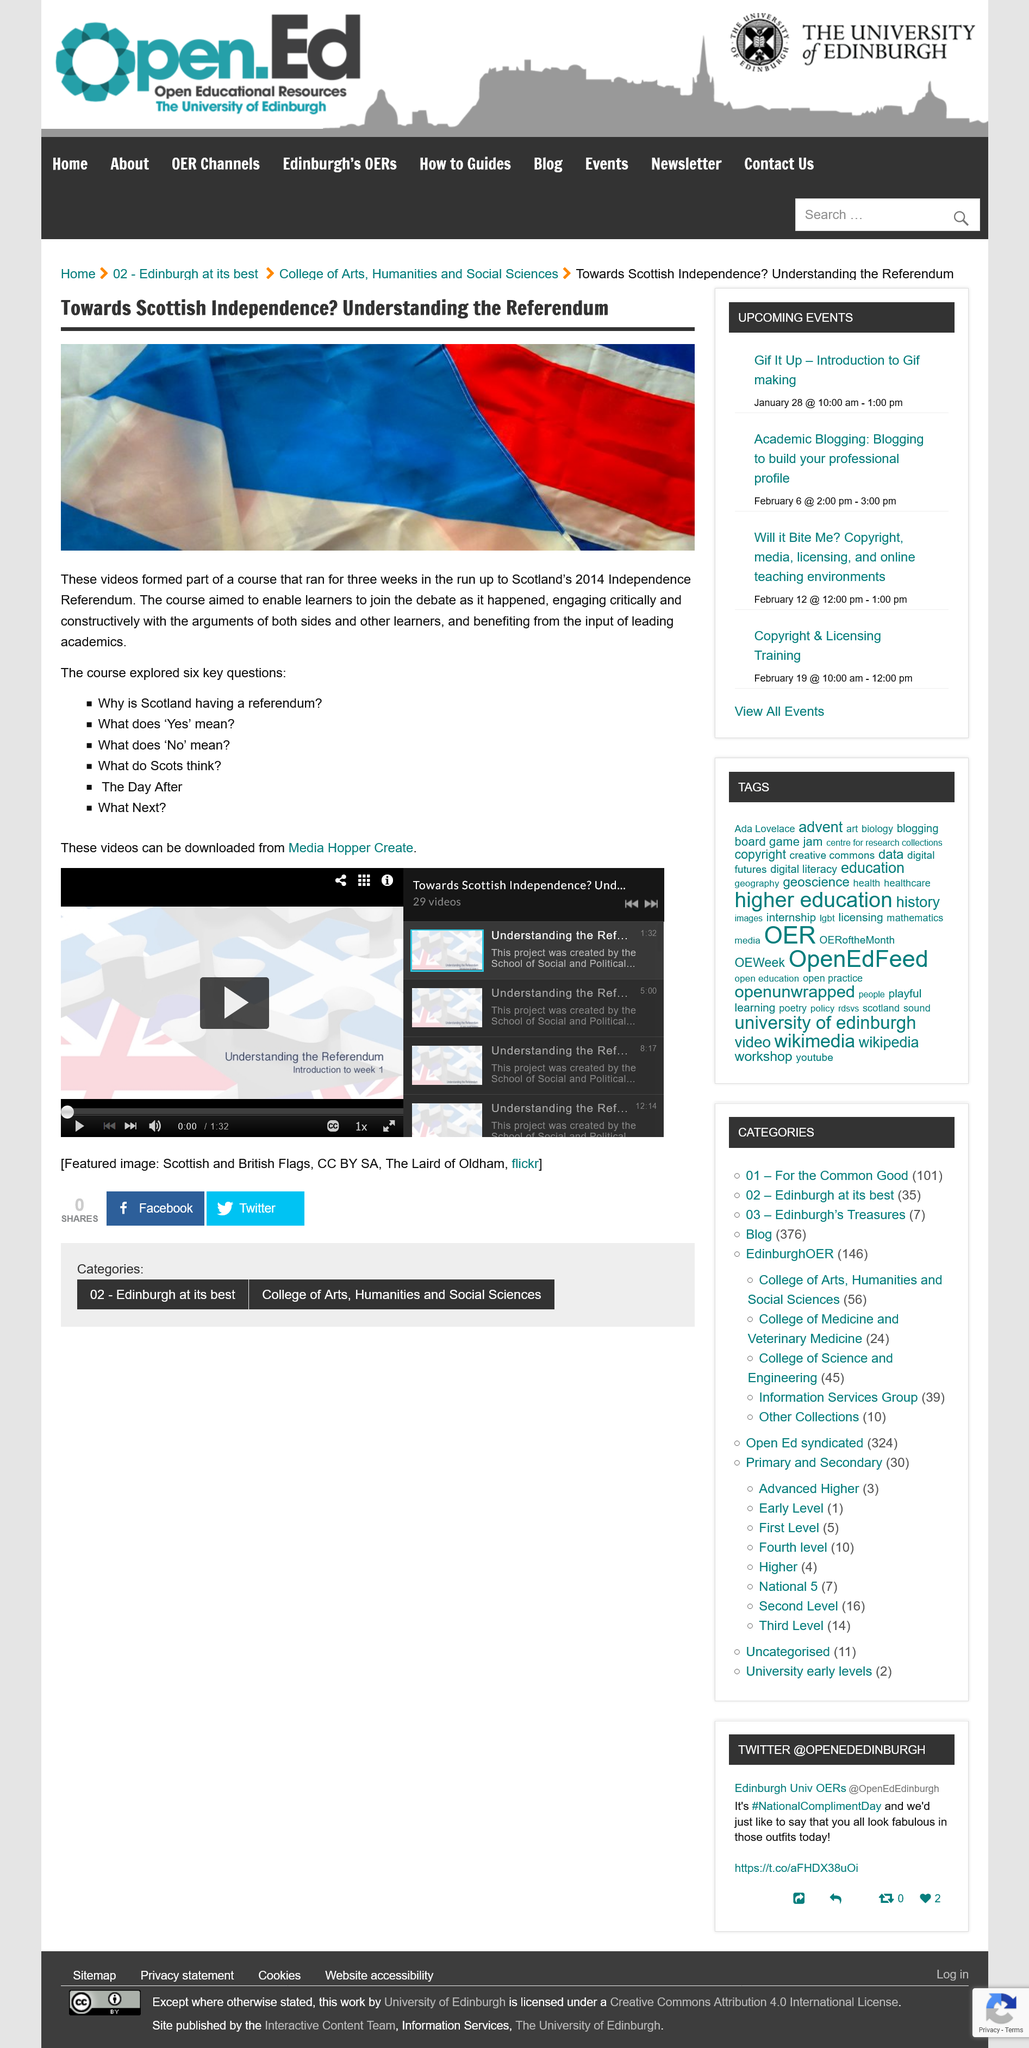Mention a couple of crucial points in this snapshot. Scotland's Independence Referendum is scheduled to take place in 2014. Scotland held an independence referendum in 2014. There are a total of six key questions. 